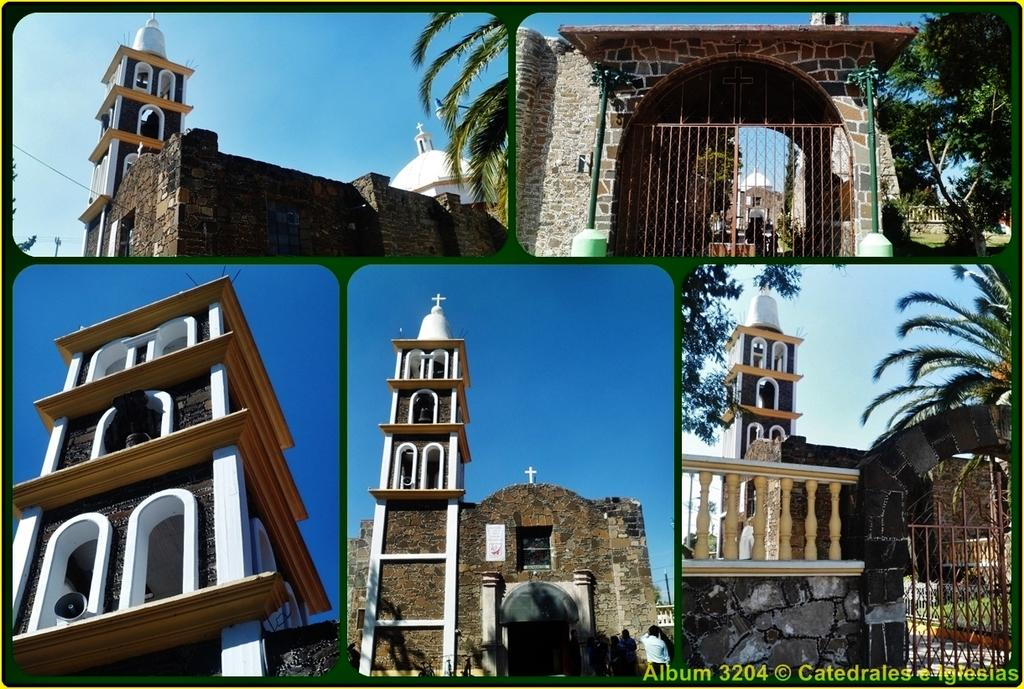What type of structure is present in the image? There is a building in the image. What is the color of the building? The building is brown in color. What can be seen in the background of the image? There are trees and the sky visible in the background of the image. What is the color of the trees? The trees are green in color. What is the color of the sky? The sky is blue in color. Can you see the smile on the building's face in the image? There is no face or smile present on the building in the image. 